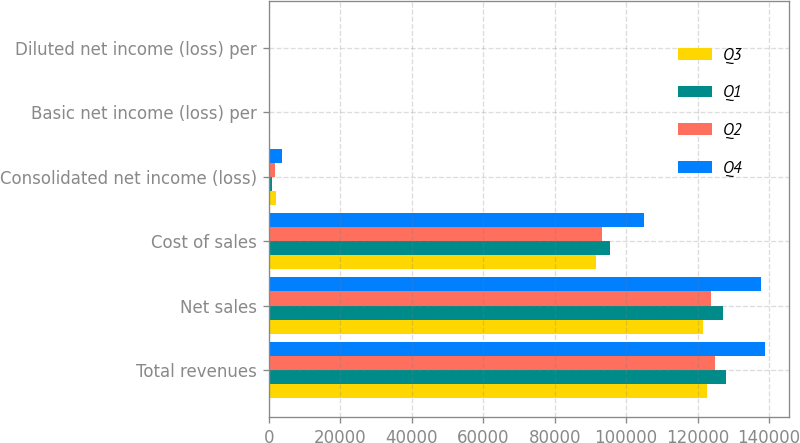<chart> <loc_0><loc_0><loc_500><loc_500><stacked_bar_chart><ecel><fcel>Total revenues<fcel>Net sales<fcel>Cost of sales<fcel>Consolidated net income (loss)<fcel>Basic net income (loss) per<fcel>Diluted net income (loss) per<nl><fcel>Q3<fcel>122690<fcel>121630<fcel>91707<fcel>2134<fcel>0.72<fcel>0.72<nl><fcel>Q1<fcel>128028<fcel>127059<fcel>95571<fcel>861<fcel>0.29<fcel>0.29<nl><fcel>Q2<fcel>124894<fcel>123897<fcel>93116<fcel>1710<fcel>0.58<fcel>0.58<nl><fcel>Q4<fcel>138793<fcel>137743<fcel>104907<fcel>3687<fcel>1.27<fcel>1.27<nl></chart> 